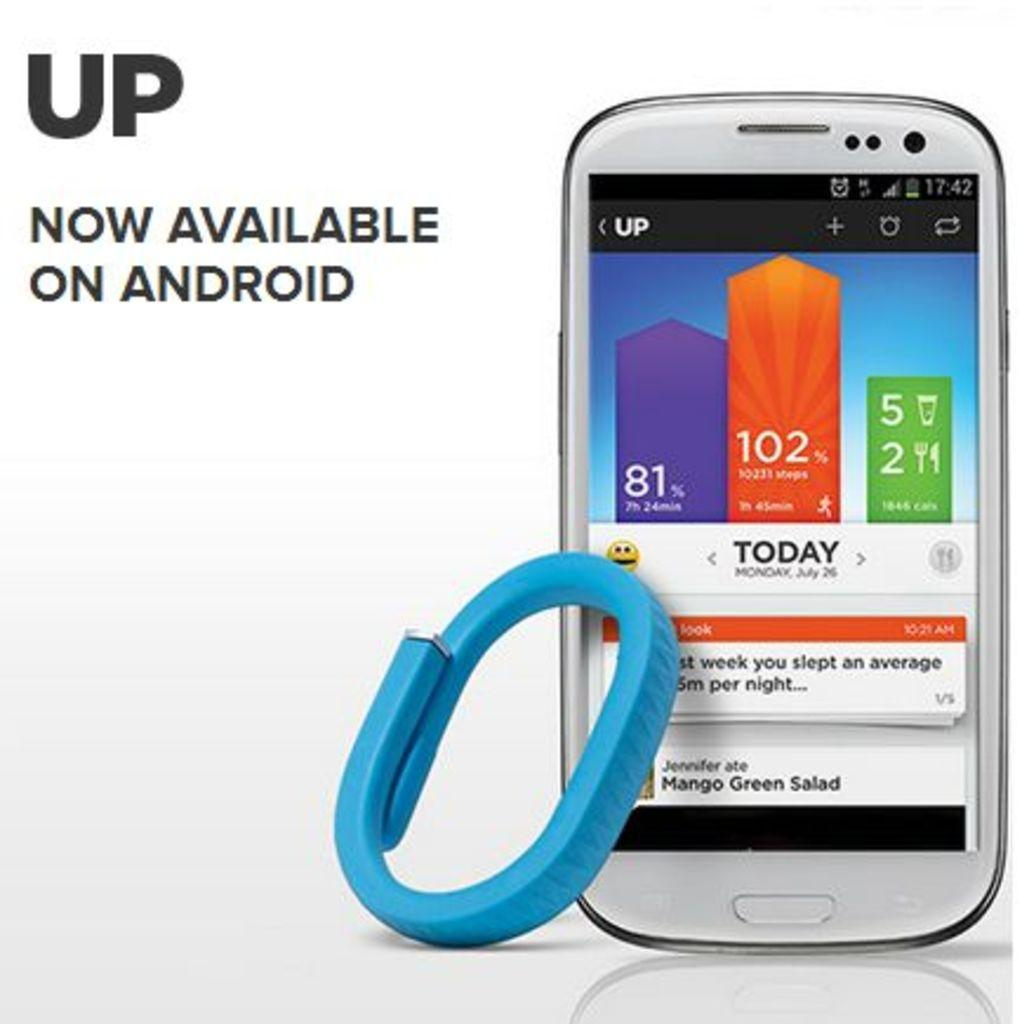<image>
Describe the image concisely. a phone that has the word 102 on it 